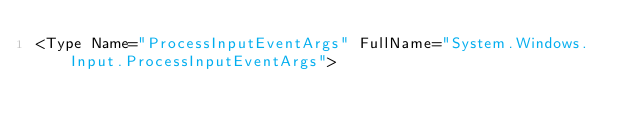Convert code to text. <code><loc_0><loc_0><loc_500><loc_500><_XML_><Type Name="ProcessInputEventArgs" FullName="System.Windows.Input.ProcessInputEventArgs"></code> 